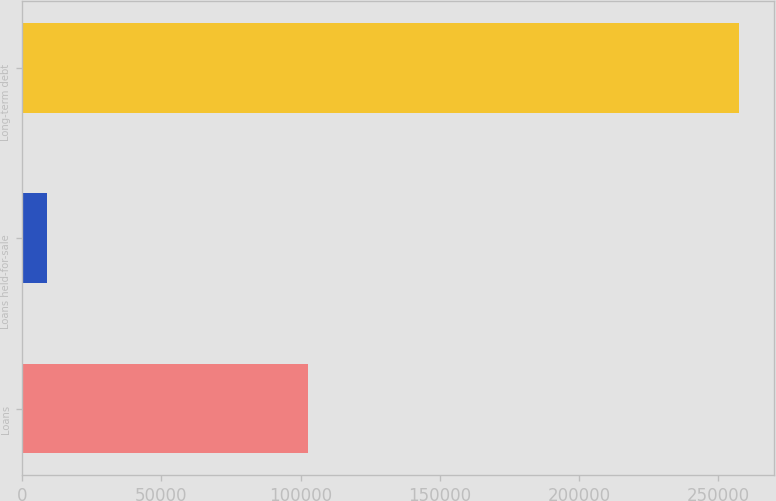Convert chart to OTSL. <chart><loc_0><loc_0><loc_500><loc_500><bar_chart><fcel>Loans<fcel>Loans held-for-sale<fcel>Long-term debt<nl><fcel>102564<fcel>8872<fcel>257402<nl></chart> 